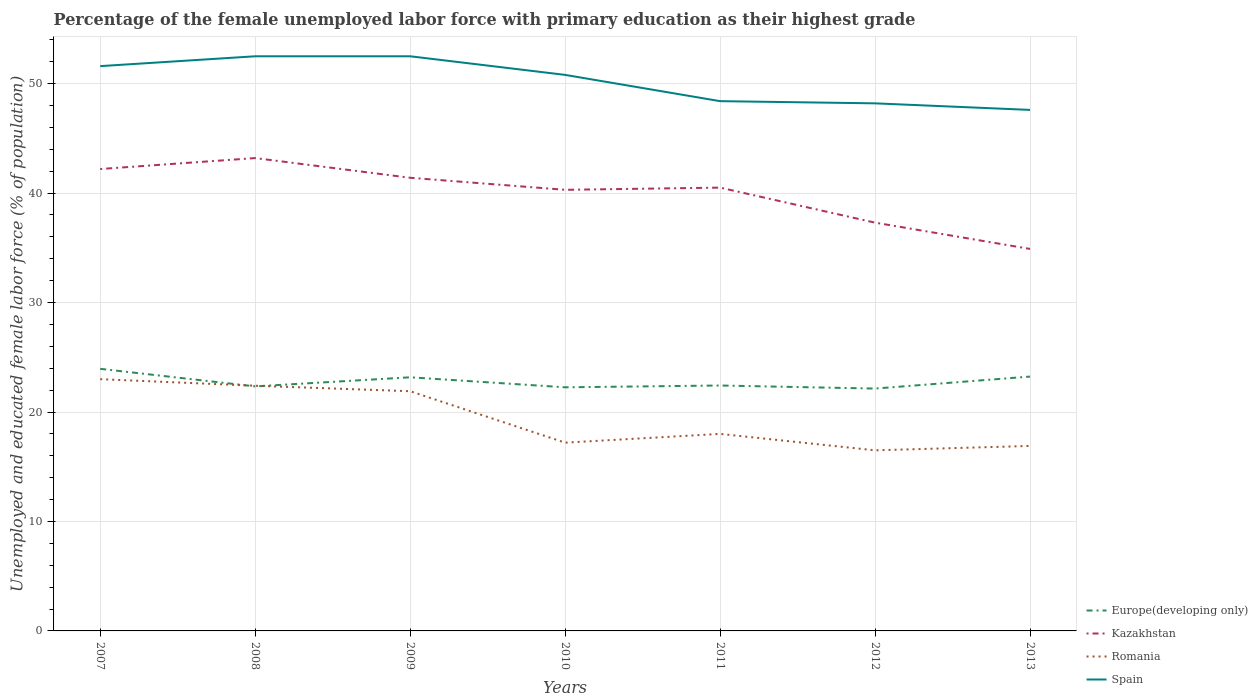How many different coloured lines are there?
Keep it short and to the point. 4. Does the line corresponding to Spain intersect with the line corresponding to Europe(developing only)?
Your answer should be compact. No. Is the number of lines equal to the number of legend labels?
Offer a terse response. Yes. Across all years, what is the maximum percentage of the unemployed female labor force with primary education in Spain?
Provide a short and direct response. 47.6. In which year was the percentage of the unemployed female labor force with primary education in Spain maximum?
Make the answer very short. 2013. What is the total percentage of the unemployed female labor force with primary education in Spain in the graph?
Give a very brief answer. 2.4. What is the difference between the highest and the second highest percentage of the unemployed female labor force with primary education in Europe(developing only)?
Offer a very short reply. 1.8. How many lines are there?
Provide a succinct answer. 4. How many years are there in the graph?
Your answer should be very brief. 7. Does the graph contain grids?
Keep it short and to the point. Yes. Where does the legend appear in the graph?
Keep it short and to the point. Bottom right. How many legend labels are there?
Provide a short and direct response. 4. What is the title of the graph?
Offer a very short reply. Percentage of the female unemployed labor force with primary education as their highest grade. Does "Chad" appear as one of the legend labels in the graph?
Your answer should be very brief. No. What is the label or title of the Y-axis?
Provide a succinct answer. Unemployed and educated female labor force (% of population). What is the Unemployed and educated female labor force (% of population) of Europe(developing only) in 2007?
Offer a terse response. 23.95. What is the Unemployed and educated female labor force (% of population) in Kazakhstan in 2007?
Offer a very short reply. 42.2. What is the Unemployed and educated female labor force (% of population) in Romania in 2007?
Keep it short and to the point. 23. What is the Unemployed and educated female labor force (% of population) of Spain in 2007?
Offer a terse response. 51.6. What is the Unemployed and educated female labor force (% of population) of Europe(developing only) in 2008?
Make the answer very short. 22.34. What is the Unemployed and educated female labor force (% of population) of Kazakhstan in 2008?
Provide a succinct answer. 43.2. What is the Unemployed and educated female labor force (% of population) of Romania in 2008?
Your answer should be compact. 22.4. What is the Unemployed and educated female labor force (% of population) of Spain in 2008?
Give a very brief answer. 52.5. What is the Unemployed and educated female labor force (% of population) in Europe(developing only) in 2009?
Your answer should be compact. 23.17. What is the Unemployed and educated female labor force (% of population) in Kazakhstan in 2009?
Your response must be concise. 41.4. What is the Unemployed and educated female labor force (% of population) in Romania in 2009?
Your response must be concise. 21.9. What is the Unemployed and educated female labor force (% of population) of Spain in 2009?
Give a very brief answer. 52.5. What is the Unemployed and educated female labor force (% of population) of Europe(developing only) in 2010?
Your answer should be very brief. 22.26. What is the Unemployed and educated female labor force (% of population) in Kazakhstan in 2010?
Keep it short and to the point. 40.3. What is the Unemployed and educated female labor force (% of population) of Romania in 2010?
Your answer should be very brief. 17.2. What is the Unemployed and educated female labor force (% of population) of Spain in 2010?
Provide a succinct answer. 50.8. What is the Unemployed and educated female labor force (% of population) in Europe(developing only) in 2011?
Keep it short and to the point. 22.42. What is the Unemployed and educated female labor force (% of population) in Kazakhstan in 2011?
Ensure brevity in your answer.  40.5. What is the Unemployed and educated female labor force (% of population) of Spain in 2011?
Provide a succinct answer. 48.4. What is the Unemployed and educated female labor force (% of population) in Europe(developing only) in 2012?
Offer a very short reply. 22.14. What is the Unemployed and educated female labor force (% of population) in Kazakhstan in 2012?
Your response must be concise. 37.3. What is the Unemployed and educated female labor force (% of population) in Spain in 2012?
Your answer should be very brief. 48.2. What is the Unemployed and educated female labor force (% of population) in Europe(developing only) in 2013?
Ensure brevity in your answer.  23.24. What is the Unemployed and educated female labor force (% of population) in Kazakhstan in 2013?
Your answer should be compact. 34.9. What is the Unemployed and educated female labor force (% of population) of Romania in 2013?
Your answer should be very brief. 16.9. What is the Unemployed and educated female labor force (% of population) of Spain in 2013?
Offer a very short reply. 47.6. Across all years, what is the maximum Unemployed and educated female labor force (% of population) in Europe(developing only)?
Provide a succinct answer. 23.95. Across all years, what is the maximum Unemployed and educated female labor force (% of population) of Kazakhstan?
Make the answer very short. 43.2. Across all years, what is the maximum Unemployed and educated female labor force (% of population) of Spain?
Offer a terse response. 52.5. Across all years, what is the minimum Unemployed and educated female labor force (% of population) in Europe(developing only)?
Make the answer very short. 22.14. Across all years, what is the minimum Unemployed and educated female labor force (% of population) in Kazakhstan?
Your answer should be very brief. 34.9. Across all years, what is the minimum Unemployed and educated female labor force (% of population) of Romania?
Your response must be concise. 16.5. Across all years, what is the minimum Unemployed and educated female labor force (% of population) in Spain?
Ensure brevity in your answer.  47.6. What is the total Unemployed and educated female labor force (% of population) of Europe(developing only) in the graph?
Your response must be concise. 159.52. What is the total Unemployed and educated female labor force (% of population) of Kazakhstan in the graph?
Offer a terse response. 279.8. What is the total Unemployed and educated female labor force (% of population) of Romania in the graph?
Offer a terse response. 135.9. What is the total Unemployed and educated female labor force (% of population) in Spain in the graph?
Keep it short and to the point. 351.6. What is the difference between the Unemployed and educated female labor force (% of population) in Europe(developing only) in 2007 and that in 2008?
Provide a succinct answer. 1.6. What is the difference between the Unemployed and educated female labor force (% of population) in Kazakhstan in 2007 and that in 2008?
Your answer should be compact. -1. What is the difference between the Unemployed and educated female labor force (% of population) of Romania in 2007 and that in 2008?
Offer a very short reply. 0.6. What is the difference between the Unemployed and educated female labor force (% of population) of Spain in 2007 and that in 2008?
Provide a short and direct response. -0.9. What is the difference between the Unemployed and educated female labor force (% of population) in Europe(developing only) in 2007 and that in 2009?
Provide a succinct answer. 0.77. What is the difference between the Unemployed and educated female labor force (% of population) of Kazakhstan in 2007 and that in 2009?
Provide a short and direct response. 0.8. What is the difference between the Unemployed and educated female labor force (% of population) of Romania in 2007 and that in 2009?
Offer a terse response. 1.1. What is the difference between the Unemployed and educated female labor force (% of population) in Spain in 2007 and that in 2009?
Provide a succinct answer. -0.9. What is the difference between the Unemployed and educated female labor force (% of population) in Europe(developing only) in 2007 and that in 2010?
Give a very brief answer. 1.69. What is the difference between the Unemployed and educated female labor force (% of population) of Spain in 2007 and that in 2010?
Offer a very short reply. 0.8. What is the difference between the Unemployed and educated female labor force (% of population) in Europe(developing only) in 2007 and that in 2011?
Make the answer very short. 1.52. What is the difference between the Unemployed and educated female labor force (% of population) of Kazakhstan in 2007 and that in 2011?
Your response must be concise. 1.7. What is the difference between the Unemployed and educated female labor force (% of population) in Romania in 2007 and that in 2011?
Provide a succinct answer. 5. What is the difference between the Unemployed and educated female labor force (% of population) of Europe(developing only) in 2007 and that in 2012?
Make the answer very short. 1.8. What is the difference between the Unemployed and educated female labor force (% of population) of Spain in 2007 and that in 2012?
Your answer should be compact. 3.4. What is the difference between the Unemployed and educated female labor force (% of population) of Europe(developing only) in 2007 and that in 2013?
Provide a succinct answer. 0.71. What is the difference between the Unemployed and educated female labor force (% of population) in Kazakhstan in 2007 and that in 2013?
Keep it short and to the point. 7.3. What is the difference between the Unemployed and educated female labor force (% of population) of Europe(developing only) in 2008 and that in 2009?
Ensure brevity in your answer.  -0.83. What is the difference between the Unemployed and educated female labor force (% of population) in Kazakhstan in 2008 and that in 2009?
Offer a terse response. 1.8. What is the difference between the Unemployed and educated female labor force (% of population) in Romania in 2008 and that in 2009?
Your response must be concise. 0.5. What is the difference between the Unemployed and educated female labor force (% of population) of Spain in 2008 and that in 2009?
Offer a very short reply. 0. What is the difference between the Unemployed and educated female labor force (% of population) in Europe(developing only) in 2008 and that in 2010?
Give a very brief answer. 0.08. What is the difference between the Unemployed and educated female labor force (% of population) of Romania in 2008 and that in 2010?
Your answer should be very brief. 5.2. What is the difference between the Unemployed and educated female labor force (% of population) of Europe(developing only) in 2008 and that in 2011?
Your answer should be very brief. -0.08. What is the difference between the Unemployed and educated female labor force (% of population) of Kazakhstan in 2008 and that in 2011?
Offer a terse response. 2.7. What is the difference between the Unemployed and educated female labor force (% of population) in Romania in 2008 and that in 2011?
Your answer should be very brief. 4.4. What is the difference between the Unemployed and educated female labor force (% of population) in Europe(developing only) in 2008 and that in 2012?
Provide a short and direct response. 0.2. What is the difference between the Unemployed and educated female labor force (% of population) in Romania in 2008 and that in 2012?
Make the answer very short. 5.9. What is the difference between the Unemployed and educated female labor force (% of population) in Spain in 2008 and that in 2012?
Offer a terse response. 4.3. What is the difference between the Unemployed and educated female labor force (% of population) of Europe(developing only) in 2008 and that in 2013?
Your answer should be compact. -0.9. What is the difference between the Unemployed and educated female labor force (% of population) of Romania in 2008 and that in 2013?
Ensure brevity in your answer.  5.5. What is the difference between the Unemployed and educated female labor force (% of population) of Spain in 2008 and that in 2013?
Your response must be concise. 4.9. What is the difference between the Unemployed and educated female labor force (% of population) in Europe(developing only) in 2009 and that in 2010?
Ensure brevity in your answer.  0.92. What is the difference between the Unemployed and educated female labor force (% of population) in Kazakhstan in 2009 and that in 2010?
Offer a very short reply. 1.1. What is the difference between the Unemployed and educated female labor force (% of population) of Romania in 2009 and that in 2010?
Offer a terse response. 4.7. What is the difference between the Unemployed and educated female labor force (% of population) in Europe(developing only) in 2009 and that in 2011?
Offer a very short reply. 0.75. What is the difference between the Unemployed and educated female labor force (% of population) of Kazakhstan in 2009 and that in 2011?
Make the answer very short. 0.9. What is the difference between the Unemployed and educated female labor force (% of population) in Romania in 2009 and that in 2011?
Make the answer very short. 3.9. What is the difference between the Unemployed and educated female labor force (% of population) in Spain in 2009 and that in 2011?
Give a very brief answer. 4.1. What is the difference between the Unemployed and educated female labor force (% of population) in Europe(developing only) in 2009 and that in 2012?
Give a very brief answer. 1.03. What is the difference between the Unemployed and educated female labor force (% of population) in Kazakhstan in 2009 and that in 2012?
Your answer should be compact. 4.1. What is the difference between the Unemployed and educated female labor force (% of population) of Romania in 2009 and that in 2012?
Keep it short and to the point. 5.4. What is the difference between the Unemployed and educated female labor force (% of population) in Spain in 2009 and that in 2012?
Your response must be concise. 4.3. What is the difference between the Unemployed and educated female labor force (% of population) of Europe(developing only) in 2009 and that in 2013?
Offer a terse response. -0.07. What is the difference between the Unemployed and educated female labor force (% of population) of Kazakhstan in 2009 and that in 2013?
Your answer should be compact. 6.5. What is the difference between the Unemployed and educated female labor force (% of population) in Romania in 2009 and that in 2013?
Keep it short and to the point. 5. What is the difference between the Unemployed and educated female labor force (% of population) in Europe(developing only) in 2010 and that in 2011?
Ensure brevity in your answer.  -0.16. What is the difference between the Unemployed and educated female labor force (% of population) in Kazakhstan in 2010 and that in 2011?
Offer a very short reply. -0.2. What is the difference between the Unemployed and educated female labor force (% of population) in Spain in 2010 and that in 2011?
Your response must be concise. 2.4. What is the difference between the Unemployed and educated female labor force (% of population) of Europe(developing only) in 2010 and that in 2012?
Give a very brief answer. 0.11. What is the difference between the Unemployed and educated female labor force (% of population) of Europe(developing only) in 2010 and that in 2013?
Make the answer very short. -0.98. What is the difference between the Unemployed and educated female labor force (% of population) in Kazakhstan in 2010 and that in 2013?
Your answer should be very brief. 5.4. What is the difference between the Unemployed and educated female labor force (% of population) in Spain in 2010 and that in 2013?
Provide a succinct answer. 3.2. What is the difference between the Unemployed and educated female labor force (% of population) of Europe(developing only) in 2011 and that in 2012?
Your answer should be very brief. 0.28. What is the difference between the Unemployed and educated female labor force (% of population) of Romania in 2011 and that in 2012?
Provide a succinct answer. 1.5. What is the difference between the Unemployed and educated female labor force (% of population) in Spain in 2011 and that in 2012?
Ensure brevity in your answer.  0.2. What is the difference between the Unemployed and educated female labor force (% of population) of Europe(developing only) in 2011 and that in 2013?
Offer a very short reply. -0.82. What is the difference between the Unemployed and educated female labor force (% of population) in Spain in 2011 and that in 2013?
Provide a short and direct response. 0.8. What is the difference between the Unemployed and educated female labor force (% of population) in Europe(developing only) in 2012 and that in 2013?
Offer a terse response. -1.1. What is the difference between the Unemployed and educated female labor force (% of population) of Europe(developing only) in 2007 and the Unemployed and educated female labor force (% of population) of Kazakhstan in 2008?
Ensure brevity in your answer.  -19.25. What is the difference between the Unemployed and educated female labor force (% of population) of Europe(developing only) in 2007 and the Unemployed and educated female labor force (% of population) of Romania in 2008?
Give a very brief answer. 1.55. What is the difference between the Unemployed and educated female labor force (% of population) in Europe(developing only) in 2007 and the Unemployed and educated female labor force (% of population) in Spain in 2008?
Offer a terse response. -28.55. What is the difference between the Unemployed and educated female labor force (% of population) of Kazakhstan in 2007 and the Unemployed and educated female labor force (% of population) of Romania in 2008?
Your response must be concise. 19.8. What is the difference between the Unemployed and educated female labor force (% of population) of Romania in 2007 and the Unemployed and educated female labor force (% of population) of Spain in 2008?
Your answer should be compact. -29.5. What is the difference between the Unemployed and educated female labor force (% of population) in Europe(developing only) in 2007 and the Unemployed and educated female labor force (% of population) in Kazakhstan in 2009?
Keep it short and to the point. -17.45. What is the difference between the Unemployed and educated female labor force (% of population) in Europe(developing only) in 2007 and the Unemployed and educated female labor force (% of population) in Romania in 2009?
Ensure brevity in your answer.  2.05. What is the difference between the Unemployed and educated female labor force (% of population) of Europe(developing only) in 2007 and the Unemployed and educated female labor force (% of population) of Spain in 2009?
Your response must be concise. -28.55. What is the difference between the Unemployed and educated female labor force (% of population) in Kazakhstan in 2007 and the Unemployed and educated female labor force (% of population) in Romania in 2009?
Make the answer very short. 20.3. What is the difference between the Unemployed and educated female labor force (% of population) in Romania in 2007 and the Unemployed and educated female labor force (% of population) in Spain in 2009?
Make the answer very short. -29.5. What is the difference between the Unemployed and educated female labor force (% of population) of Europe(developing only) in 2007 and the Unemployed and educated female labor force (% of population) of Kazakhstan in 2010?
Give a very brief answer. -16.35. What is the difference between the Unemployed and educated female labor force (% of population) of Europe(developing only) in 2007 and the Unemployed and educated female labor force (% of population) of Romania in 2010?
Your response must be concise. 6.75. What is the difference between the Unemployed and educated female labor force (% of population) of Europe(developing only) in 2007 and the Unemployed and educated female labor force (% of population) of Spain in 2010?
Your answer should be very brief. -26.85. What is the difference between the Unemployed and educated female labor force (% of population) in Kazakhstan in 2007 and the Unemployed and educated female labor force (% of population) in Romania in 2010?
Offer a terse response. 25. What is the difference between the Unemployed and educated female labor force (% of population) in Romania in 2007 and the Unemployed and educated female labor force (% of population) in Spain in 2010?
Ensure brevity in your answer.  -27.8. What is the difference between the Unemployed and educated female labor force (% of population) of Europe(developing only) in 2007 and the Unemployed and educated female labor force (% of population) of Kazakhstan in 2011?
Your answer should be compact. -16.55. What is the difference between the Unemployed and educated female labor force (% of population) in Europe(developing only) in 2007 and the Unemployed and educated female labor force (% of population) in Romania in 2011?
Your answer should be very brief. 5.95. What is the difference between the Unemployed and educated female labor force (% of population) in Europe(developing only) in 2007 and the Unemployed and educated female labor force (% of population) in Spain in 2011?
Your response must be concise. -24.45. What is the difference between the Unemployed and educated female labor force (% of population) in Kazakhstan in 2007 and the Unemployed and educated female labor force (% of population) in Romania in 2011?
Your answer should be very brief. 24.2. What is the difference between the Unemployed and educated female labor force (% of population) of Romania in 2007 and the Unemployed and educated female labor force (% of population) of Spain in 2011?
Offer a terse response. -25.4. What is the difference between the Unemployed and educated female labor force (% of population) in Europe(developing only) in 2007 and the Unemployed and educated female labor force (% of population) in Kazakhstan in 2012?
Ensure brevity in your answer.  -13.35. What is the difference between the Unemployed and educated female labor force (% of population) in Europe(developing only) in 2007 and the Unemployed and educated female labor force (% of population) in Romania in 2012?
Ensure brevity in your answer.  7.45. What is the difference between the Unemployed and educated female labor force (% of population) in Europe(developing only) in 2007 and the Unemployed and educated female labor force (% of population) in Spain in 2012?
Your response must be concise. -24.25. What is the difference between the Unemployed and educated female labor force (% of population) in Kazakhstan in 2007 and the Unemployed and educated female labor force (% of population) in Romania in 2012?
Keep it short and to the point. 25.7. What is the difference between the Unemployed and educated female labor force (% of population) in Romania in 2007 and the Unemployed and educated female labor force (% of population) in Spain in 2012?
Your answer should be very brief. -25.2. What is the difference between the Unemployed and educated female labor force (% of population) of Europe(developing only) in 2007 and the Unemployed and educated female labor force (% of population) of Kazakhstan in 2013?
Keep it short and to the point. -10.95. What is the difference between the Unemployed and educated female labor force (% of population) of Europe(developing only) in 2007 and the Unemployed and educated female labor force (% of population) of Romania in 2013?
Provide a short and direct response. 7.05. What is the difference between the Unemployed and educated female labor force (% of population) in Europe(developing only) in 2007 and the Unemployed and educated female labor force (% of population) in Spain in 2013?
Offer a very short reply. -23.65. What is the difference between the Unemployed and educated female labor force (% of population) of Kazakhstan in 2007 and the Unemployed and educated female labor force (% of population) of Romania in 2013?
Keep it short and to the point. 25.3. What is the difference between the Unemployed and educated female labor force (% of population) in Kazakhstan in 2007 and the Unemployed and educated female labor force (% of population) in Spain in 2013?
Provide a short and direct response. -5.4. What is the difference between the Unemployed and educated female labor force (% of population) in Romania in 2007 and the Unemployed and educated female labor force (% of population) in Spain in 2013?
Provide a succinct answer. -24.6. What is the difference between the Unemployed and educated female labor force (% of population) of Europe(developing only) in 2008 and the Unemployed and educated female labor force (% of population) of Kazakhstan in 2009?
Keep it short and to the point. -19.06. What is the difference between the Unemployed and educated female labor force (% of population) of Europe(developing only) in 2008 and the Unemployed and educated female labor force (% of population) of Romania in 2009?
Your answer should be compact. 0.44. What is the difference between the Unemployed and educated female labor force (% of population) in Europe(developing only) in 2008 and the Unemployed and educated female labor force (% of population) in Spain in 2009?
Offer a terse response. -30.16. What is the difference between the Unemployed and educated female labor force (% of population) in Kazakhstan in 2008 and the Unemployed and educated female labor force (% of population) in Romania in 2009?
Give a very brief answer. 21.3. What is the difference between the Unemployed and educated female labor force (% of population) of Romania in 2008 and the Unemployed and educated female labor force (% of population) of Spain in 2009?
Your answer should be very brief. -30.1. What is the difference between the Unemployed and educated female labor force (% of population) of Europe(developing only) in 2008 and the Unemployed and educated female labor force (% of population) of Kazakhstan in 2010?
Your answer should be compact. -17.96. What is the difference between the Unemployed and educated female labor force (% of population) in Europe(developing only) in 2008 and the Unemployed and educated female labor force (% of population) in Romania in 2010?
Keep it short and to the point. 5.14. What is the difference between the Unemployed and educated female labor force (% of population) in Europe(developing only) in 2008 and the Unemployed and educated female labor force (% of population) in Spain in 2010?
Offer a terse response. -28.46. What is the difference between the Unemployed and educated female labor force (% of population) in Romania in 2008 and the Unemployed and educated female labor force (% of population) in Spain in 2010?
Give a very brief answer. -28.4. What is the difference between the Unemployed and educated female labor force (% of population) of Europe(developing only) in 2008 and the Unemployed and educated female labor force (% of population) of Kazakhstan in 2011?
Your response must be concise. -18.16. What is the difference between the Unemployed and educated female labor force (% of population) in Europe(developing only) in 2008 and the Unemployed and educated female labor force (% of population) in Romania in 2011?
Provide a succinct answer. 4.34. What is the difference between the Unemployed and educated female labor force (% of population) in Europe(developing only) in 2008 and the Unemployed and educated female labor force (% of population) in Spain in 2011?
Your response must be concise. -26.06. What is the difference between the Unemployed and educated female labor force (% of population) in Kazakhstan in 2008 and the Unemployed and educated female labor force (% of population) in Romania in 2011?
Your response must be concise. 25.2. What is the difference between the Unemployed and educated female labor force (% of population) in Kazakhstan in 2008 and the Unemployed and educated female labor force (% of population) in Spain in 2011?
Offer a very short reply. -5.2. What is the difference between the Unemployed and educated female labor force (% of population) in Romania in 2008 and the Unemployed and educated female labor force (% of population) in Spain in 2011?
Make the answer very short. -26. What is the difference between the Unemployed and educated female labor force (% of population) in Europe(developing only) in 2008 and the Unemployed and educated female labor force (% of population) in Kazakhstan in 2012?
Your answer should be compact. -14.96. What is the difference between the Unemployed and educated female labor force (% of population) in Europe(developing only) in 2008 and the Unemployed and educated female labor force (% of population) in Romania in 2012?
Provide a succinct answer. 5.84. What is the difference between the Unemployed and educated female labor force (% of population) in Europe(developing only) in 2008 and the Unemployed and educated female labor force (% of population) in Spain in 2012?
Provide a succinct answer. -25.86. What is the difference between the Unemployed and educated female labor force (% of population) of Kazakhstan in 2008 and the Unemployed and educated female labor force (% of population) of Romania in 2012?
Give a very brief answer. 26.7. What is the difference between the Unemployed and educated female labor force (% of population) of Romania in 2008 and the Unemployed and educated female labor force (% of population) of Spain in 2012?
Make the answer very short. -25.8. What is the difference between the Unemployed and educated female labor force (% of population) of Europe(developing only) in 2008 and the Unemployed and educated female labor force (% of population) of Kazakhstan in 2013?
Your answer should be compact. -12.56. What is the difference between the Unemployed and educated female labor force (% of population) in Europe(developing only) in 2008 and the Unemployed and educated female labor force (% of population) in Romania in 2013?
Keep it short and to the point. 5.44. What is the difference between the Unemployed and educated female labor force (% of population) of Europe(developing only) in 2008 and the Unemployed and educated female labor force (% of population) of Spain in 2013?
Your answer should be very brief. -25.26. What is the difference between the Unemployed and educated female labor force (% of population) in Kazakhstan in 2008 and the Unemployed and educated female labor force (% of population) in Romania in 2013?
Keep it short and to the point. 26.3. What is the difference between the Unemployed and educated female labor force (% of population) of Kazakhstan in 2008 and the Unemployed and educated female labor force (% of population) of Spain in 2013?
Make the answer very short. -4.4. What is the difference between the Unemployed and educated female labor force (% of population) in Romania in 2008 and the Unemployed and educated female labor force (% of population) in Spain in 2013?
Your response must be concise. -25.2. What is the difference between the Unemployed and educated female labor force (% of population) in Europe(developing only) in 2009 and the Unemployed and educated female labor force (% of population) in Kazakhstan in 2010?
Give a very brief answer. -17.13. What is the difference between the Unemployed and educated female labor force (% of population) of Europe(developing only) in 2009 and the Unemployed and educated female labor force (% of population) of Romania in 2010?
Offer a very short reply. 5.97. What is the difference between the Unemployed and educated female labor force (% of population) in Europe(developing only) in 2009 and the Unemployed and educated female labor force (% of population) in Spain in 2010?
Keep it short and to the point. -27.63. What is the difference between the Unemployed and educated female labor force (% of population) in Kazakhstan in 2009 and the Unemployed and educated female labor force (% of population) in Romania in 2010?
Provide a short and direct response. 24.2. What is the difference between the Unemployed and educated female labor force (% of population) in Kazakhstan in 2009 and the Unemployed and educated female labor force (% of population) in Spain in 2010?
Provide a short and direct response. -9.4. What is the difference between the Unemployed and educated female labor force (% of population) of Romania in 2009 and the Unemployed and educated female labor force (% of population) of Spain in 2010?
Keep it short and to the point. -28.9. What is the difference between the Unemployed and educated female labor force (% of population) of Europe(developing only) in 2009 and the Unemployed and educated female labor force (% of population) of Kazakhstan in 2011?
Keep it short and to the point. -17.33. What is the difference between the Unemployed and educated female labor force (% of population) of Europe(developing only) in 2009 and the Unemployed and educated female labor force (% of population) of Romania in 2011?
Ensure brevity in your answer.  5.17. What is the difference between the Unemployed and educated female labor force (% of population) of Europe(developing only) in 2009 and the Unemployed and educated female labor force (% of population) of Spain in 2011?
Offer a terse response. -25.23. What is the difference between the Unemployed and educated female labor force (% of population) in Kazakhstan in 2009 and the Unemployed and educated female labor force (% of population) in Romania in 2011?
Your answer should be very brief. 23.4. What is the difference between the Unemployed and educated female labor force (% of population) in Romania in 2009 and the Unemployed and educated female labor force (% of population) in Spain in 2011?
Offer a very short reply. -26.5. What is the difference between the Unemployed and educated female labor force (% of population) in Europe(developing only) in 2009 and the Unemployed and educated female labor force (% of population) in Kazakhstan in 2012?
Provide a short and direct response. -14.13. What is the difference between the Unemployed and educated female labor force (% of population) in Europe(developing only) in 2009 and the Unemployed and educated female labor force (% of population) in Romania in 2012?
Provide a short and direct response. 6.67. What is the difference between the Unemployed and educated female labor force (% of population) of Europe(developing only) in 2009 and the Unemployed and educated female labor force (% of population) of Spain in 2012?
Make the answer very short. -25.03. What is the difference between the Unemployed and educated female labor force (% of population) of Kazakhstan in 2009 and the Unemployed and educated female labor force (% of population) of Romania in 2012?
Offer a very short reply. 24.9. What is the difference between the Unemployed and educated female labor force (% of population) in Romania in 2009 and the Unemployed and educated female labor force (% of population) in Spain in 2012?
Make the answer very short. -26.3. What is the difference between the Unemployed and educated female labor force (% of population) of Europe(developing only) in 2009 and the Unemployed and educated female labor force (% of population) of Kazakhstan in 2013?
Your answer should be compact. -11.73. What is the difference between the Unemployed and educated female labor force (% of population) in Europe(developing only) in 2009 and the Unemployed and educated female labor force (% of population) in Romania in 2013?
Ensure brevity in your answer.  6.27. What is the difference between the Unemployed and educated female labor force (% of population) in Europe(developing only) in 2009 and the Unemployed and educated female labor force (% of population) in Spain in 2013?
Provide a succinct answer. -24.43. What is the difference between the Unemployed and educated female labor force (% of population) of Kazakhstan in 2009 and the Unemployed and educated female labor force (% of population) of Spain in 2013?
Keep it short and to the point. -6.2. What is the difference between the Unemployed and educated female labor force (% of population) of Romania in 2009 and the Unemployed and educated female labor force (% of population) of Spain in 2013?
Offer a very short reply. -25.7. What is the difference between the Unemployed and educated female labor force (% of population) of Europe(developing only) in 2010 and the Unemployed and educated female labor force (% of population) of Kazakhstan in 2011?
Ensure brevity in your answer.  -18.24. What is the difference between the Unemployed and educated female labor force (% of population) in Europe(developing only) in 2010 and the Unemployed and educated female labor force (% of population) in Romania in 2011?
Ensure brevity in your answer.  4.26. What is the difference between the Unemployed and educated female labor force (% of population) of Europe(developing only) in 2010 and the Unemployed and educated female labor force (% of population) of Spain in 2011?
Offer a very short reply. -26.14. What is the difference between the Unemployed and educated female labor force (% of population) in Kazakhstan in 2010 and the Unemployed and educated female labor force (% of population) in Romania in 2011?
Ensure brevity in your answer.  22.3. What is the difference between the Unemployed and educated female labor force (% of population) of Kazakhstan in 2010 and the Unemployed and educated female labor force (% of population) of Spain in 2011?
Give a very brief answer. -8.1. What is the difference between the Unemployed and educated female labor force (% of population) of Romania in 2010 and the Unemployed and educated female labor force (% of population) of Spain in 2011?
Provide a short and direct response. -31.2. What is the difference between the Unemployed and educated female labor force (% of population) of Europe(developing only) in 2010 and the Unemployed and educated female labor force (% of population) of Kazakhstan in 2012?
Offer a terse response. -15.04. What is the difference between the Unemployed and educated female labor force (% of population) of Europe(developing only) in 2010 and the Unemployed and educated female labor force (% of population) of Romania in 2012?
Keep it short and to the point. 5.76. What is the difference between the Unemployed and educated female labor force (% of population) of Europe(developing only) in 2010 and the Unemployed and educated female labor force (% of population) of Spain in 2012?
Ensure brevity in your answer.  -25.94. What is the difference between the Unemployed and educated female labor force (% of population) of Kazakhstan in 2010 and the Unemployed and educated female labor force (% of population) of Romania in 2012?
Make the answer very short. 23.8. What is the difference between the Unemployed and educated female labor force (% of population) of Kazakhstan in 2010 and the Unemployed and educated female labor force (% of population) of Spain in 2012?
Provide a succinct answer. -7.9. What is the difference between the Unemployed and educated female labor force (% of population) of Romania in 2010 and the Unemployed and educated female labor force (% of population) of Spain in 2012?
Ensure brevity in your answer.  -31. What is the difference between the Unemployed and educated female labor force (% of population) of Europe(developing only) in 2010 and the Unemployed and educated female labor force (% of population) of Kazakhstan in 2013?
Your answer should be very brief. -12.64. What is the difference between the Unemployed and educated female labor force (% of population) of Europe(developing only) in 2010 and the Unemployed and educated female labor force (% of population) of Romania in 2013?
Make the answer very short. 5.36. What is the difference between the Unemployed and educated female labor force (% of population) in Europe(developing only) in 2010 and the Unemployed and educated female labor force (% of population) in Spain in 2013?
Make the answer very short. -25.34. What is the difference between the Unemployed and educated female labor force (% of population) of Kazakhstan in 2010 and the Unemployed and educated female labor force (% of population) of Romania in 2013?
Keep it short and to the point. 23.4. What is the difference between the Unemployed and educated female labor force (% of population) of Kazakhstan in 2010 and the Unemployed and educated female labor force (% of population) of Spain in 2013?
Provide a succinct answer. -7.3. What is the difference between the Unemployed and educated female labor force (% of population) in Romania in 2010 and the Unemployed and educated female labor force (% of population) in Spain in 2013?
Provide a succinct answer. -30.4. What is the difference between the Unemployed and educated female labor force (% of population) in Europe(developing only) in 2011 and the Unemployed and educated female labor force (% of population) in Kazakhstan in 2012?
Your answer should be compact. -14.88. What is the difference between the Unemployed and educated female labor force (% of population) of Europe(developing only) in 2011 and the Unemployed and educated female labor force (% of population) of Romania in 2012?
Your answer should be compact. 5.92. What is the difference between the Unemployed and educated female labor force (% of population) of Europe(developing only) in 2011 and the Unemployed and educated female labor force (% of population) of Spain in 2012?
Keep it short and to the point. -25.78. What is the difference between the Unemployed and educated female labor force (% of population) of Kazakhstan in 2011 and the Unemployed and educated female labor force (% of population) of Romania in 2012?
Make the answer very short. 24. What is the difference between the Unemployed and educated female labor force (% of population) of Kazakhstan in 2011 and the Unemployed and educated female labor force (% of population) of Spain in 2012?
Your answer should be very brief. -7.7. What is the difference between the Unemployed and educated female labor force (% of population) in Romania in 2011 and the Unemployed and educated female labor force (% of population) in Spain in 2012?
Give a very brief answer. -30.2. What is the difference between the Unemployed and educated female labor force (% of population) of Europe(developing only) in 2011 and the Unemployed and educated female labor force (% of population) of Kazakhstan in 2013?
Provide a short and direct response. -12.48. What is the difference between the Unemployed and educated female labor force (% of population) in Europe(developing only) in 2011 and the Unemployed and educated female labor force (% of population) in Romania in 2013?
Keep it short and to the point. 5.52. What is the difference between the Unemployed and educated female labor force (% of population) of Europe(developing only) in 2011 and the Unemployed and educated female labor force (% of population) of Spain in 2013?
Offer a very short reply. -25.18. What is the difference between the Unemployed and educated female labor force (% of population) of Kazakhstan in 2011 and the Unemployed and educated female labor force (% of population) of Romania in 2013?
Give a very brief answer. 23.6. What is the difference between the Unemployed and educated female labor force (% of population) of Romania in 2011 and the Unemployed and educated female labor force (% of population) of Spain in 2013?
Your response must be concise. -29.6. What is the difference between the Unemployed and educated female labor force (% of population) in Europe(developing only) in 2012 and the Unemployed and educated female labor force (% of population) in Kazakhstan in 2013?
Offer a terse response. -12.76. What is the difference between the Unemployed and educated female labor force (% of population) in Europe(developing only) in 2012 and the Unemployed and educated female labor force (% of population) in Romania in 2013?
Make the answer very short. 5.24. What is the difference between the Unemployed and educated female labor force (% of population) in Europe(developing only) in 2012 and the Unemployed and educated female labor force (% of population) in Spain in 2013?
Provide a succinct answer. -25.46. What is the difference between the Unemployed and educated female labor force (% of population) in Kazakhstan in 2012 and the Unemployed and educated female labor force (% of population) in Romania in 2013?
Keep it short and to the point. 20.4. What is the difference between the Unemployed and educated female labor force (% of population) of Romania in 2012 and the Unemployed and educated female labor force (% of population) of Spain in 2013?
Make the answer very short. -31.1. What is the average Unemployed and educated female labor force (% of population) in Europe(developing only) per year?
Make the answer very short. 22.79. What is the average Unemployed and educated female labor force (% of population) in Kazakhstan per year?
Offer a terse response. 39.97. What is the average Unemployed and educated female labor force (% of population) of Romania per year?
Offer a terse response. 19.41. What is the average Unemployed and educated female labor force (% of population) of Spain per year?
Provide a succinct answer. 50.23. In the year 2007, what is the difference between the Unemployed and educated female labor force (% of population) of Europe(developing only) and Unemployed and educated female labor force (% of population) of Kazakhstan?
Provide a short and direct response. -18.25. In the year 2007, what is the difference between the Unemployed and educated female labor force (% of population) in Europe(developing only) and Unemployed and educated female labor force (% of population) in Romania?
Your answer should be very brief. 0.95. In the year 2007, what is the difference between the Unemployed and educated female labor force (% of population) in Europe(developing only) and Unemployed and educated female labor force (% of population) in Spain?
Keep it short and to the point. -27.65. In the year 2007, what is the difference between the Unemployed and educated female labor force (% of population) in Kazakhstan and Unemployed and educated female labor force (% of population) in Romania?
Ensure brevity in your answer.  19.2. In the year 2007, what is the difference between the Unemployed and educated female labor force (% of population) in Kazakhstan and Unemployed and educated female labor force (% of population) in Spain?
Your response must be concise. -9.4. In the year 2007, what is the difference between the Unemployed and educated female labor force (% of population) in Romania and Unemployed and educated female labor force (% of population) in Spain?
Offer a terse response. -28.6. In the year 2008, what is the difference between the Unemployed and educated female labor force (% of population) of Europe(developing only) and Unemployed and educated female labor force (% of population) of Kazakhstan?
Your answer should be very brief. -20.86. In the year 2008, what is the difference between the Unemployed and educated female labor force (% of population) in Europe(developing only) and Unemployed and educated female labor force (% of population) in Romania?
Offer a terse response. -0.06. In the year 2008, what is the difference between the Unemployed and educated female labor force (% of population) of Europe(developing only) and Unemployed and educated female labor force (% of population) of Spain?
Give a very brief answer. -30.16. In the year 2008, what is the difference between the Unemployed and educated female labor force (% of population) in Kazakhstan and Unemployed and educated female labor force (% of population) in Romania?
Keep it short and to the point. 20.8. In the year 2008, what is the difference between the Unemployed and educated female labor force (% of population) of Romania and Unemployed and educated female labor force (% of population) of Spain?
Provide a short and direct response. -30.1. In the year 2009, what is the difference between the Unemployed and educated female labor force (% of population) in Europe(developing only) and Unemployed and educated female labor force (% of population) in Kazakhstan?
Ensure brevity in your answer.  -18.23. In the year 2009, what is the difference between the Unemployed and educated female labor force (% of population) in Europe(developing only) and Unemployed and educated female labor force (% of population) in Romania?
Your answer should be very brief. 1.27. In the year 2009, what is the difference between the Unemployed and educated female labor force (% of population) in Europe(developing only) and Unemployed and educated female labor force (% of population) in Spain?
Make the answer very short. -29.33. In the year 2009, what is the difference between the Unemployed and educated female labor force (% of population) in Romania and Unemployed and educated female labor force (% of population) in Spain?
Your answer should be very brief. -30.6. In the year 2010, what is the difference between the Unemployed and educated female labor force (% of population) in Europe(developing only) and Unemployed and educated female labor force (% of population) in Kazakhstan?
Your answer should be compact. -18.04. In the year 2010, what is the difference between the Unemployed and educated female labor force (% of population) of Europe(developing only) and Unemployed and educated female labor force (% of population) of Romania?
Keep it short and to the point. 5.06. In the year 2010, what is the difference between the Unemployed and educated female labor force (% of population) in Europe(developing only) and Unemployed and educated female labor force (% of population) in Spain?
Your answer should be very brief. -28.54. In the year 2010, what is the difference between the Unemployed and educated female labor force (% of population) in Kazakhstan and Unemployed and educated female labor force (% of population) in Romania?
Your answer should be very brief. 23.1. In the year 2010, what is the difference between the Unemployed and educated female labor force (% of population) in Romania and Unemployed and educated female labor force (% of population) in Spain?
Your response must be concise. -33.6. In the year 2011, what is the difference between the Unemployed and educated female labor force (% of population) of Europe(developing only) and Unemployed and educated female labor force (% of population) of Kazakhstan?
Give a very brief answer. -18.08. In the year 2011, what is the difference between the Unemployed and educated female labor force (% of population) in Europe(developing only) and Unemployed and educated female labor force (% of population) in Romania?
Your answer should be very brief. 4.42. In the year 2011, what is the difference between the Unemployed and educated female labor force (% of population) of Europe(developing only) and Unemployed and educated female labor force (% of population) of Spain?
Your response must be concise. -25.98. In the year 2011, what is the difference between the Unemployed and educated female labor force (% of population) of Kazakhstan and Unemployed and educated female labor force (% of population) of Romania?
Make the answer very short. 22.5. In the year 2011, what is the difference between the Unemployed and educated female labor force (% of population) of Kazakhstan and Unemployed and educated female labor force (% of population) of Spain?
Ensure brevity in your answer.  -7.9. In the year 2011, what is the difference between the Unemployed and educated female labor force (% of population) in Romania and Unemployed and educated female labor force (% of population) in Spain?
Ensure brevity in your answer.  -30.4. In the year 2012, what is the difference between the Unemployed and educated female labor force (% of population) in Europe(developing only) and Unemployed and educated female labor force (% of population) in Kazakhstan?
Your answer should be compact. -15.16. In the year 2012, what is the difference between the Unemployed and educated female labor force (% of population) of Europe(developing only) and Unemployed and educated female labor force (% of population) of Romania?
Provide a short and direct response. 5.64. In the year 2012, what is the difference between the Unemployed and educated female labor force (% of population) in Europe(developing only) and Unemployed and educated female labor force (% of population) in Spain?
Your answer should be very brief. -26.06. In the year 2012, what is the difference between the Unemployed and educated female labor force (% of population) of Kazakhstan and Unemployed and educated female labor force (% of population) of Romania?
Make the answer very short. 20.8. In the year 2012, what is the difference between the Unemployed and educated female labor force (% of population) in Kazakhstan and Unemployed and educated female labor force (% of population) in Spain?
Your answer should be very brief. -10.9. In the year 2012, what is the difference between the Unemployed and educated female labor force (% of population) of Romania and Unemployed and educated female labor force (% of population) of Spain?
Offer a very short reply. -31.7. In the year 2013, what is the difference between the Unemployed and educated female labor force (% of population) of Europe(developing only) and Unemployed and educated female labor force (% of population) of Kazakhstan?
Your response must be concise. -11.66. In the year 2013, what is the difference between the Unemployed and educated female labor force (% of population) in Europe(developing only) and Unemployed and educated female labor force (% of population) in Romania?
Provide a short and direct response. 6.34. In the year 2013, what is the difference between the Unemployed and educated female labor force (% of population) in Europe(developing only) and Unemployed and educated female labor force (% of population) in Spain?
Make the answer very short. -24.36. In the year 2013, what is the difference between the Unemployed and educated female labor force (% of population) in Kazakhstan and Unemployed and educated female labor force (% of population) in Spain?
Keep it short and to the point. -12.7. In the year 2013, what is the difference between the Unemployed and educated female labor force (% of population) of Romania and Unemployed and educated female labor force (% of population) of Spain?
Provide a short and direct response. -30.7. What is the ratio of the Unemployed and educated female labor force (% of population) of Europe(developing only) in 2007 to that in 2008?
Give a very brief answer. 1.07. What is the ratio of the Unemployed and educated female labor force (% of population) in Kazakhstan in 2007 to that in 2008?
Your answer should be very brief. 0.98. What is the ratio of the Unemployed and educated female labor force (% of population) in Romania in 2007 to that in 2008?
Provide a succinct answer. 1.03. What is the ratio of the Unemployed and educated female labor force (% of population) of Spain in 2007 to that in 2008?
Offer a terse response. 0.98. What is the ratio of the Unemployed and educated female labor force (% of population) in Europe(developing only) in 2007 to that in 2009?
Provide a short and direct response. 1.03. What is the ratio of the Unemployed and educated female labor force (% of population) in Kazakhstan in 2007 to that in 2009?
Your answer should be compact. 1.02. What is the ratio of the Unemployed and educated female labor force (% of population) of Romania in 2007 to that in 2009?
Make the answer very short. 1.05. What is the ratio of the Unemployed and educated female labor force (% of population) in Spain in 2007 to that in 2009?
Your answer should be compact. 0.98. What is the ratio of the Unemployed and educated female labor force (% of population) of Europe(developing only) in 2007 to that in 2010?
Your response must be concise. 1.08. What is the ratio of the Unemployed and educated female labor force (% of population) of Kazakhstan in 2007 to that in 2010?
Your answer should be compact. 1.05. What is the ratio of the Unemployed and educated female labor force (% of population) in Romania in 2007 to that in 2010?
Give a very brief answer. 1.34. What is the ratio of the Unemployed and educated female labor force (% of population) in Spain in 2007 to that in 2010?
Your answer should be very brief. 1.02. What is the ratio of the Unemployed and educated female labor force (% of population) of Europe(developing only) in 2007 to that in 2011?
Ensure brevity in your answer.  1.07. What is the ratio of the Unemployed and educated female labor force (% of population) in Kazakhstan in 2007 to that in 2011?
Provide a succinct answer. 1.04. What is the ratio of the Unemployed and educated female labor force (% of population) of Romania in 2007 to that in 2011?
Your answer should be compact. 1.28. What is the ratio of the Unemployed and educated female labor force (% of population) of Spain in 2007 to that in 2011?
Make the answer very short. 1.07. What is the ratio of the Unemployed and educated female labor force (% of population) in Europe(developing only) in 2007 to that in 2012?
Make the answer very short. 1.08. What is the ratio of the Unemployed and educated female labor force (% of population) in Kazakhstan in 2007 to that in 2012?
Your response must be concise. 1.13. What is the ratio of the Unemployed and educated female labor force (% of population) in Romania in 2007 to that in 2012?
Ensure brevity in your answer.  1.39. What is the ratio of the Unemployed and educated female labor force (% of population) of Spain in 2007 to that in 2012?
Your response must be concise. 1.07. What is the ratio of the Unemployed and educated female labor force (% of population) of Europe(developing only) in 2007 to that in 2013?
Offer a very short reply. 1.03. What is the ratio of the Unemployed and educated female labor force (% of population) of Kazakhstan in 2007 to that in 2013?
Your answer should be compact. 1.21. What is the ratio of the Unemployed and educated female labor force (% of population) of Romania in 2007 to that in 2013?
Keep it short and to the point. 1.36. What is the ratio of the Unemployed and educated female labor force (% of population) in Spain in 2007 to that in 2013?
Provide a succinct answer. 1.08. What is the ratio of the Unemployed and educated female labor force (% of population) in Europe(developing only) in 2008 to that in 2009?
Offer a very short reply. 0.96. What is the ratio of the Unemployed and educated female labor force (% of population) in Kazakhstan in 2008 to that in 2009?
Your answer should be very brief. 1.04. What is the ratio of the Unemployed and educated female labor force (% of population) of Romania in 2008 to that in 2009?
Your response must be concise. 1.02. What is the ratio of the Unemployed and educated female labor force (% of population) in Europe(developing only) in 2008 to that in 2010?
Offer a terse response. 1. What is the ratio of the Unemployed and educated female labor force (% of population) in Kazakhstan in 2008 to that in 2010?
Your answer should be very brief. 1.07. What is the ratio of the Unemployed and educated female labor force (% of population) in Romania in 2008 to that in 2010?
Provide a succinct answer. 1.3. What is the ratio of the Unemployed and educated female labor force (% of population) in Spain in 2008 to that in 2010?
Ensure brevity in your answer.  1.03. What is the ratio of the Unemployed and educated female labor force (% of population) in Kazakhstan in 2008 to that in 2011?
Keep it short and to the point. 1.07. What is the ratio of the Unemployed and educated female labor force (% of population) of Romania in 2008 to that in 2011?
Ensure brevity in your answer.  1.24. What is the ratio of the Unemployed and educated female labor force (% of population) in Spain in 2008 to that in 2011?
Your answer should be compact. 1.08. What is the ratio of the Unemployed and educated female labor force (% of population) of Europe(developing only) in 2008 to that in 2012?
Give a very brief answer. 1.01. What is the ratio of the Unemployed and educated female labor force (% of population) in Kazakhstan in 2008 to that in 2012?
Ensure brevity in your answer.  1.16. What is the ratio of the Unemployed and educated female labor force (% of population) of Romania in 2008 to that in 2012?
Offer a terse response. 1.36. What is the ratio of the Unemployed and educated female labor force (% of population) in Spain in 2008 to that in 2012?
Make the answer very short. 1.09. What is the ratio of the Unemployed and educated female labor force (% of population) in Europe(developing only) in 2008 to that in 2013?
Give a very brief answer. 0.96. What is the ratio of the Unemployed and educated female labor force (% of population) in Kazakhstan in 2008 to that in 2013?
Keep it short and to the point. 1.24. What is the ratio of the Unemployed and educated female labor force (% of population) in Romania in 2008 to that in 2013?
Provide a succinct answer. 1.33. What is the ratio of the Unemployed and educated female labor force (% of population) of Spain in 2008 to that in 2013?
Your response must be concise. 1.1. What is the ratio of the Unemployed and educated female labor force (% of population) in Europe(developing only) in 2009 to that in 2010?
Make the answer very short. 1.04. What is the ratio of the Unemployed and educated female labor force (% of population) of Kazakhstan in 2009 to that in 2010?
Offer a terse response. 1.03. What is the ratio of the Unemployed and educated female labor force (% of population) in Romania in 2009 to that in 2010?
Offer a terse response. 1.27. What is the ratio of the Unemployed and educated female labor force (% of population) in Spain in 2009 to that in 2010?
Give a very brief answer. 1.03. What is the ratio of the Unemployed and educated female labor force (% of population) in Europe(developing only) in 2009 to that in 2011?
Offer a very short reply. 1.03. What is the ratio of the Unemployed and educated female labor force (% of population) of Kazakhstan in 2009 to that in 2011?
Provide a short and direct response. 1.02. What is the ratio of the Unemployed and educated female labor force (% of population) of Romania in 2009 to that in 2011?
Provide a short and direct response. 1.22. What is the ratio of the Unemployed and educated female labor force (% of population) in Spain in 2009 to that in 2011?
Offer a terse response. 1.08. What is the ratio of the Unemployed and educated female labor force (% of population) in Europe(developing only) in 2009 to that in 2012?
Keep it short and to the point. 1.05. What is the ratio of the Unemployed and educated female labor force (% of population) of Kazakhstan in 2009 to that in 2012?
Your response must be concise. 1.11. What is the ratio of the Unemployed and educated female labor force (% of population) in Romania in 2009 to that in 2012?
Provide a short and direct response. 1.33. What is the ratio of the Unemployed and educated female labor force (% of population) in Spain in 2009 to that in 2012?
Give a very brief answer. 1.09. What is the ratio of the Unemployed and educated female labor force (% of population) of Kazakhstan in 2009 to that in 2013?
Offer a terse response. 1.19. What is the ratio of the Unemployed and educated female labor force (% of population) in Romania in 2009 to that in 2013?
Offer a very short reply. 1.3. What is the ratio of the Unemployed and educated female labor force (% of population) in Spain in 2009 to that in 2013?
Your answer should be compact. 1.1. What is the ratio of the Unemployed and educated female labor force (% of population) of Kazakhstan in 2010 to that in 2011?
Make the answer very short. 1. What is the ratio of the Unemployed and educated female labor force (% of population) in Romania in 2010 to that in 2011?
Make the answer very short. 0.96. What is the ratio of the Unemployed and educated female labor force (% of population) in Spain in 2010 to that in 2011?
Ensure brevity in your answer.  1.05. What is the ratio of the Unemployed and educated female labor force (% of population) of Europe(developing only) in 2010 to that in 2012?
Ensure brevity in your answer.  1.01. What is the ratio of the Unemployed and educated female labor force (% of population) in Kazakhstan in 2010 to that in 2012?
Your answer should be compact. 1.08. What is the ratio of the Unemployed and educated female labor force (% of population) in Romania in 2010 to that in 2012?
Offer a terse response. 1.04. What is the ratio of the Unemployed and educated female labor force (% of population) of Spain in 2010 to that in 2012?
Keep it short and to the point. 1.05. What is the ratio of the Unemployed and educated female labor force (% of population) of Europe(developing only) in 2010 to that in 2013?
Offer a terse response. 0.96. What is the ratio of the Unemployed and educated female labor force (% of population) of Kazakhstan in 2010 to that in 2013?
Your answer should be compact. 1.15. What is the ratio of the Unemployed and educated female labor force (% of population) in Romania in 2010 to that in 2013?
Offer a very short reply. 1.02. What is the ratio of the Unemployed and educated female labor force (% of population) of Spain in 2010 to that in 2013?
Keep it short and to the point. 1.07. What is the ratio of the Unemployed and educated female labor force (% of population) of Europe(developing only) in 2011 to that in 2012?
Offer a terse response. 1.01. What is the ratio of the Unemployed and educated female labor force (% of population) in Kazakhstan in 2011 to that in 2012?
Offer a terse response. 1.09. What is the ratio of the Unemployed and educated female labor force (% of population) in Europe(developing only) in 2011 to that in 2013?
Ensure brevity in your answer.  0.96. What is the ratio of the Unemployed and educated female labor force (% of population) in Kazakhstan in 2011 to that in 2013?
Provide a short and direct response. 1.16. What is the ratio of the Unemployed and educated female labor force (% of population) in Romania in 2011 to that in 2013?
Provide a short and direct response. 1.07. What is the ratio of the Unemployed and educated female labor force (% of population) of Spain in 2011 to that in 2013?
Your answer should be very brief. 1.02. What is the ratio of the Unemployed and educated female labor force (% of population) in Europe(developing only) in 2012 to that in 2013?
Provide a short and direct response. 0.95. What is the ratio of the Unemployed and educated female labor force (% of population) of Kazakhstan in 2012 to that in 2013?
Provide a succinct answer. 1.07. What is the ratio of the Unemployed and educated female labor force (% of population) in Romania in 2012 to that in 2013?
Give a very brief answer. 0.98. What is the ratio of the Unemployed and educated female labor force (% of population) in Spain in 2012 to that in 2013?
Make the answer very short. 1.01. What is the difference between the highest and the second highest Unemployed and educated female labor force (% of population) of Europe(developing only)?
Give a very brief answer. 0.71. What is the difference between the highest and the second highest Unemployed and educated female labor force (% of population) of Kazakhstan?
Provide a short and direct response. 1. What is the difference between the highest and the second highest Unemployed and educated female labor force (% of population) in Spain?
Ensure brevity in your answer.  0. What is the difference between the highest and the lowest Unemployed and educated female labor force (% of population) in Europe(developing only)?
Your answer should be very brief. 1.8. What is the difference between the highest and the lowest Unemployed and educated female labor force (% of population) of Spain?
Make the answer very short. 4.9. 